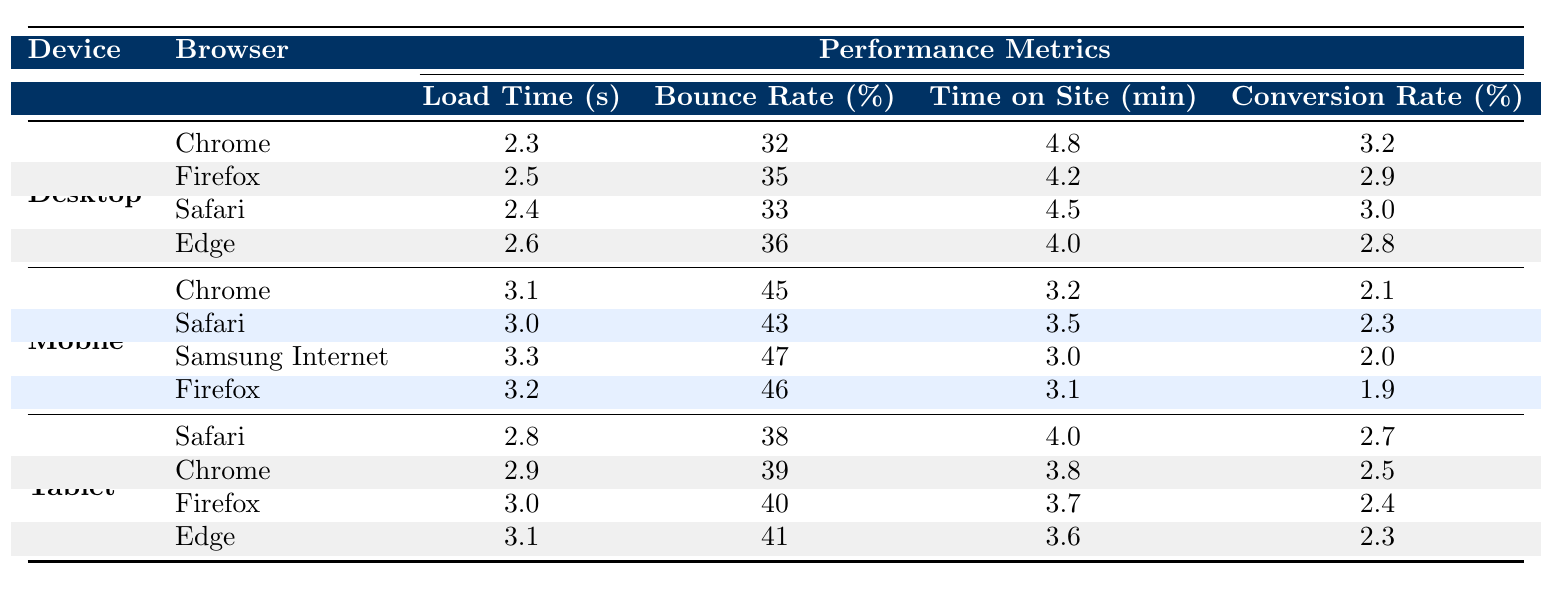What is the page load time for Chrome on Desktop? The page load time for Chrome on Desktop is directly provided in the table under the respective device and browser section. It states that the load time is 2.3 seconds.
Answer: 2.3 seconds Which browser has the highest bounce rate on Mobile? From the Mobile section of the table, we can see the bounce rates for various browsers: Chrome (45%), Safari (43%), Samsung Internet (47%), and Firefox (46%). The highest bounce rate is for Samsung Internet at 47%.
Answer: Samsung Internet What is the average time on site for Tablet users across all browsers? The time on site values for Tablets are as follows: Safari (4.0), Chrome (3.8), Firefox (3.7), and Edge (3.6). We sum them: 4.0 + 3.8 + 3.7 + 3.6 = 15.1. There are 4 data points, so we calculate the average: 15.1 / 4 = 3.775.
Answer: 3.775 minutes Is the conversion rate on Desktop better than on Mobile? The conversion rates for Desktop are: Chrome (3.2%), Firefox (2.9%), Safari (3.0%), and Edge (2.8%). The highest conversion rate for Mobile browsers is Chrome (2.1%), Safari (2.3%), Samsung Internet (2.0%), and Firefox (1.9%). The best Desktop conversion rate (3.2%) is higher than the best Mobile rate (2.3%). Therefore, the answer is yes.
Answer: Yes What is the difference in page load time between Safari on Desktop and Safari on Tablet? The page load time for Safari on Desktop is 2.4 seconds and on Tablet is 2.8 seconds. The difference is calculated by subtracting the Desktop time from the Tablet time: 2.8 - 2.4 = 0.4 seconds.
Answer: 0.4 seconds Which device type has the lowest average conversion rate? The average conversion rates by device are: Desktop (average of 3.2, 2.9, 3.0, 2.8 = 3.0), Mobile (average of 2.1, 2.3, 2.0, 1.9 = 2.3), and Tablet (average of 2.7, 2.5, 2.4, 2.3 = 2.5). The lowest average conversion rate is for Mobile, which is 2.3%.
Answer: Mobile What are the page load times for all browsers on Tablet? The page load times for Tablet browsers are: Safari (2.8 seconds), Chrome (2.9 seconds), Firefox (3.0 seconds), and Edge (3.1 seconds). This gives us a complete overview of the load times for each browser on the Tablet device type.
Answer: Safari: 2.8s, Chrome: 2.9s, Firefox: 3.0s, Edge: 3.1s Is the bounce rate for Firefox on Mobile higher than that on Desktop? The bounce rate for Firefox on Mobile is 46%, while for Firefox on Desktop, it is 35%. Since 46% is greater than 35%, we conclude that the bounce rate for Firefox on Mobile is indeed higher than on Desktop.
Answer: Yes Which browser has the longest time on site for Desktop users? By examining the time on site for Desktop browsers: Chrome (4.8 minutes), Firefox (4.2 minutes), Safari (4.5 minutes), and Edge (4.0 minutes), we find that Chrome has the longest time at 4.8 minutes.
Answer: Chrome What is the median page load time across all devices? The page load times listed in the table are: Desktop (2.3, 2.5, 2.4, 2.6), Mobile (3.1, 3.0, 3.3, 3.2), Tablet (2.8, 2.9, 3.0, 3.1). Sorting these times gives us: 2.3, 2.4, 2.5, 2.6, 2.8, 2.9, 3.0, 3.1, 3.2, 3.3. The median value is the average of the 5th and 6th values: (2.8 + 2.9) / 2 = 2.85 seconds.
Answer: 2.85 seconds 